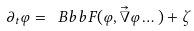<formula> <loc_0><loc_0><loc_500><loc_500>\partial _ { t } \varphi = { \ B b b F } ( \varphi , \vec { \nabla } \varphi \dots ) + \zeta</formula> 